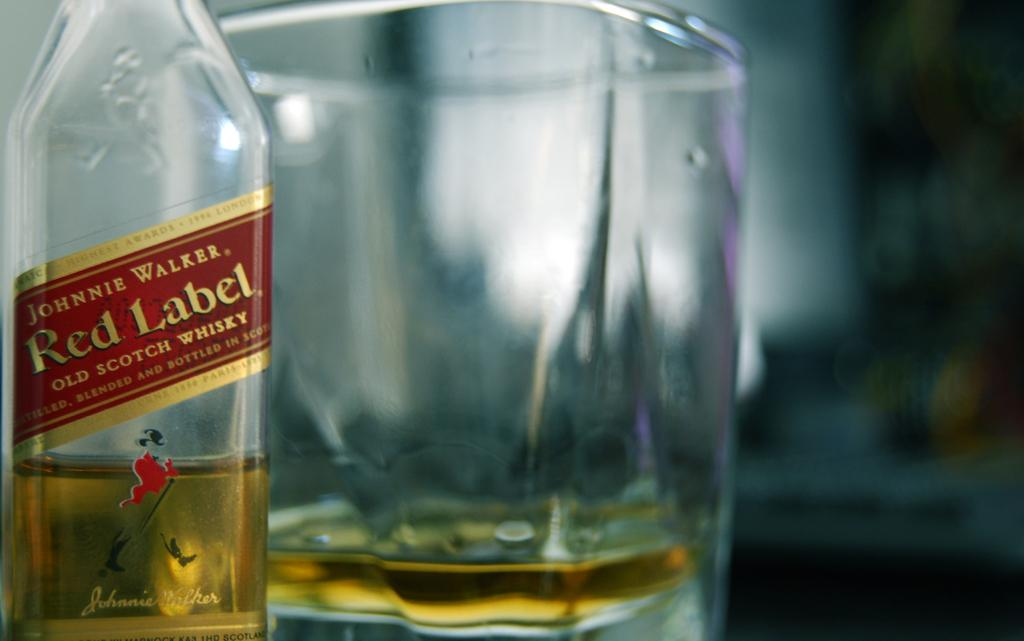<image>
Create a compact narrative representing the image presented. A bottle of Johnie Walker Red Label Wiskey. 